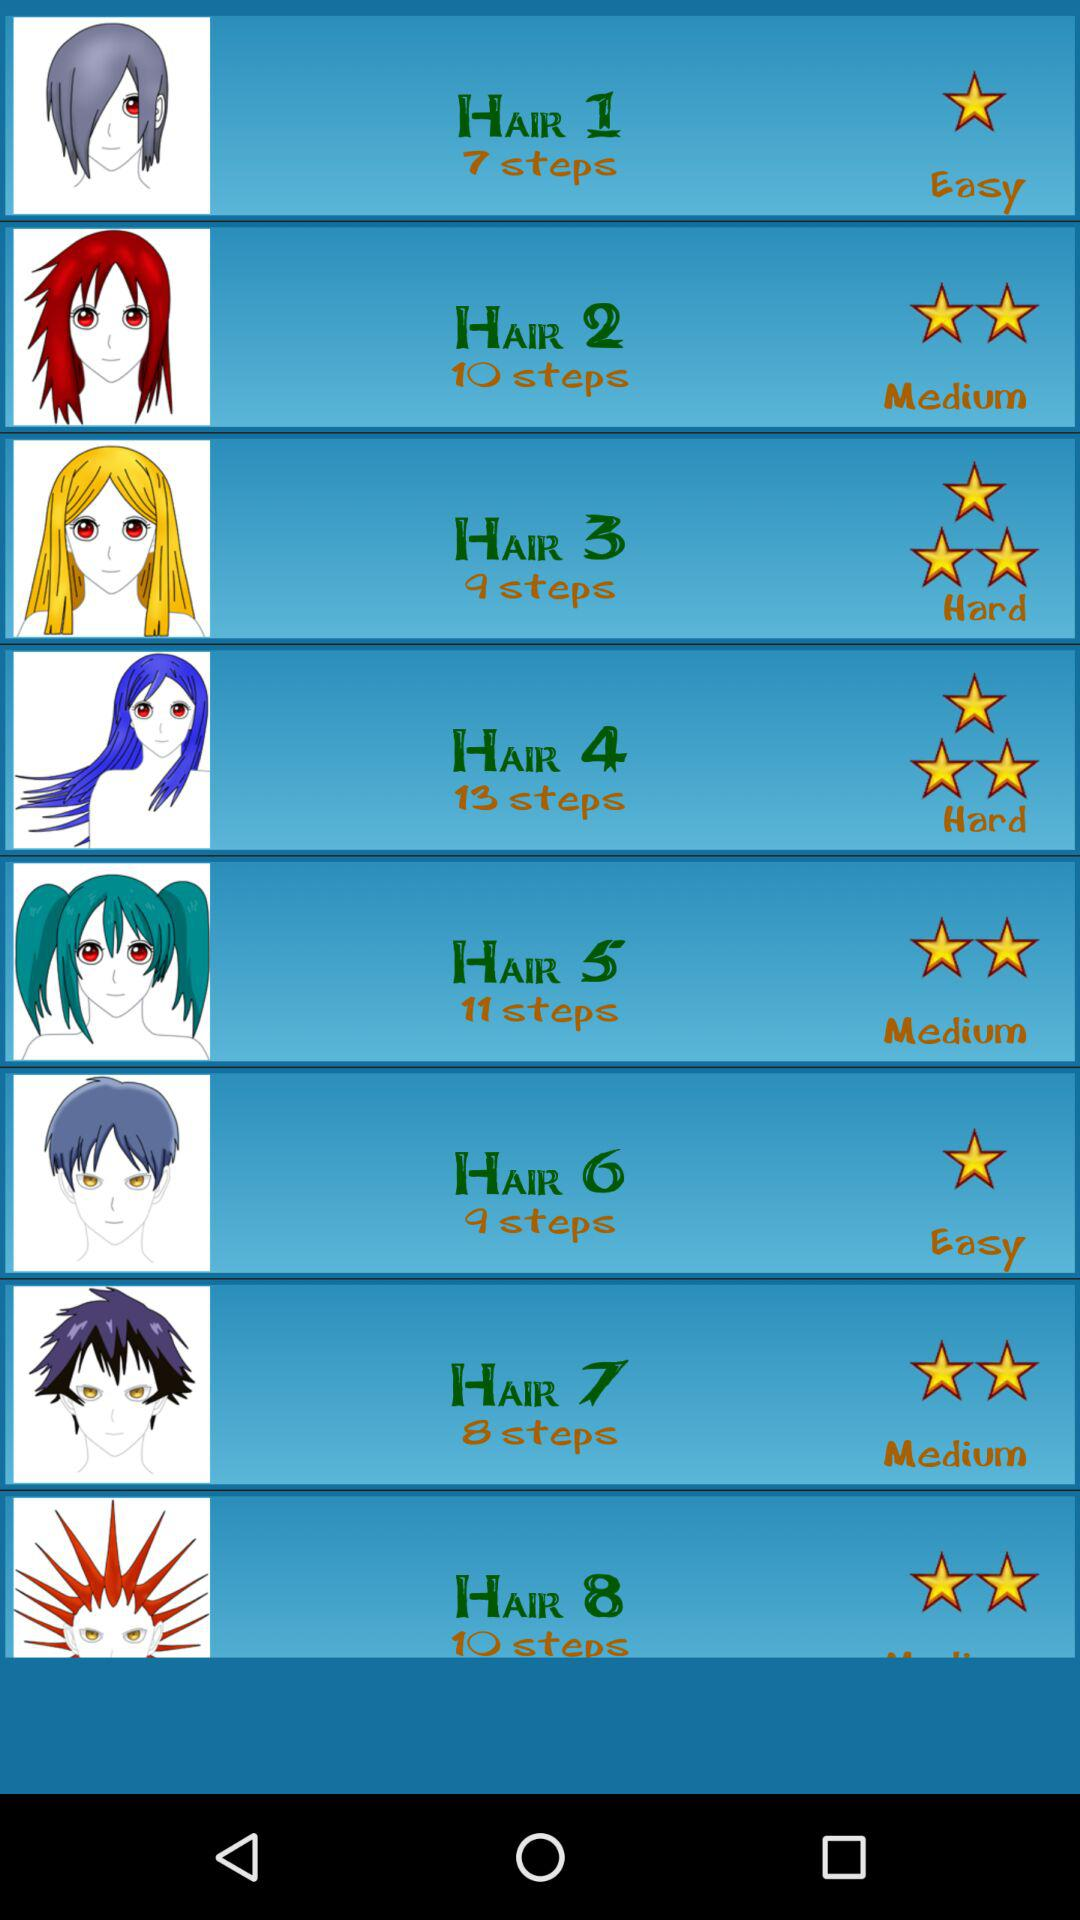Which hairstyle has nine steps? The hairstyles that have nine steps are "HAIR 3" and "HAIR 6". 